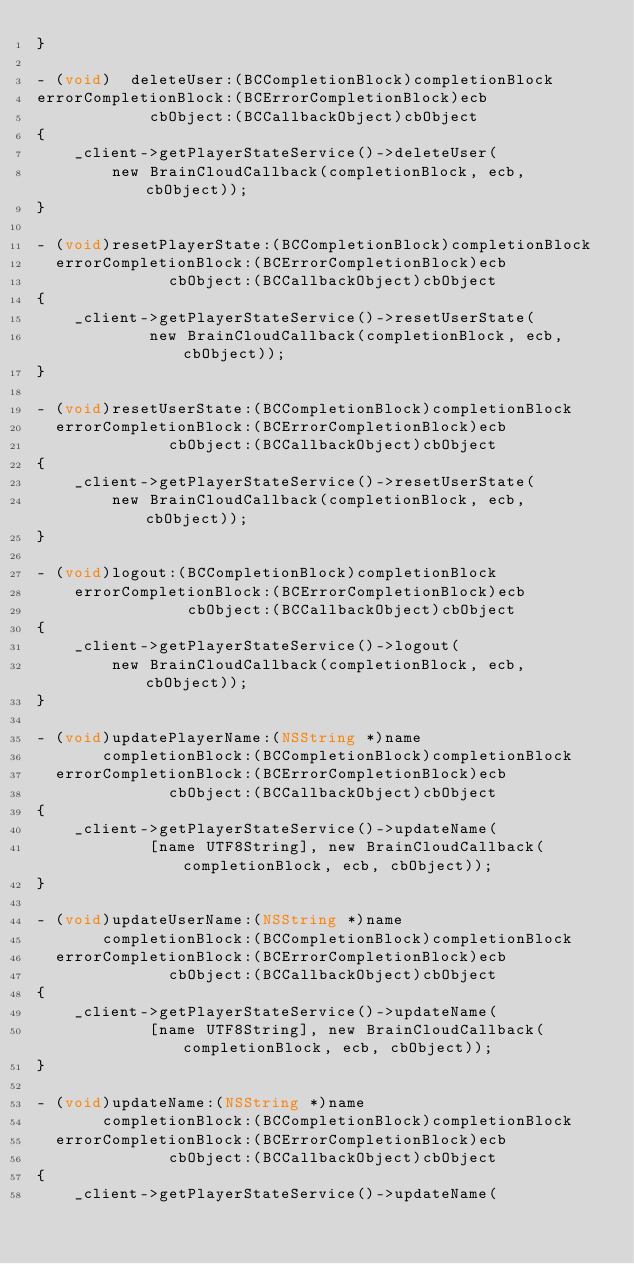Convert code to text. <code><loc_0><loc_0><loc_500><loc_500><_ObjectiveC_>}

- (void)  deleteUser:(BCCompletionBlock)completionBlock
errorCompletionBlock:(BCErrorCompletionBlock)ecb
            cbObject:(BCCallbackObject)cbObject
{
    _client->getPlayerStateService()->deleteUser(
        new BrainCloudCallback(completionBlock, ecb, cbObject));
}

- (void)resetPlayerState:(BCCompletionBlock)completionBlock
  errorCompletionBlock:(BCErrorCompletionBlock)ecb
              cbObject:(BCCallbackObject)cbObject
{
    _client->getPlayerStateService()->resetUserState(
            new BrainCloudCallback(completionBlock, ecb, cbObject));
}

- (void)resetUserState:(BCCompletionBlock)completionBlock
  errorCompletionBlock:(BCErrorCompletionBlock)ecb
              cbObject:(BCCallbackObject)cbObject
{
    _client->getPlayerStateService()->resetUserState(
        new BrainCloudCallback(completionBlock, ecb, cbObject));
}

- (void)logout:(BCCompletionBlock)completionBlock
    errorCompletionBlock:(BCErrorCompletionBlock)ecb
                cbObject:(BCCallbackObject)cbObject
{
    _client->getPlayerStateService()->logout(
        new BrainCloudCallback(completionBlock, ecb, cbObject));
}

- (void)updatePlayerName:(NSString *)name
       completionBlock:(BCCompletionBlock)completionBlock
  errorCompletionBlock:(BCErrorCompletionBlock)ecb
              cbObject:(BCCallbackObject)cbObject
{
    _client->getPlayerStateService()->updateName(
            [name UTF8String], new BrainCloudCallback(completionBlock, ecb, cbObject));
}

- (void)updateUserName:(NSString *)name
       completionBlock:(BCCompletionBlock)completionBlock
  errorCompletionBlock:(BCErrorCompletionBlock)ecb
              cbObject:(BCCallbackObject)cbObject
{
    _client->getPlayerStateService()->updateName(
            [name UTF8String], new BrainCloudCallback(completionBlock, ecb, cbObject));
}

- (void)updateName:(NSString *)name
       completionBlock:(BCCompletionBlock)completionBlock
  errorCompletionBlock:(BCErrorCompletionBlock)ecb
              cbObject:(BCCallbackObject)cbObject
{
    _client->getPlayerStateService()->updateName(</code> 